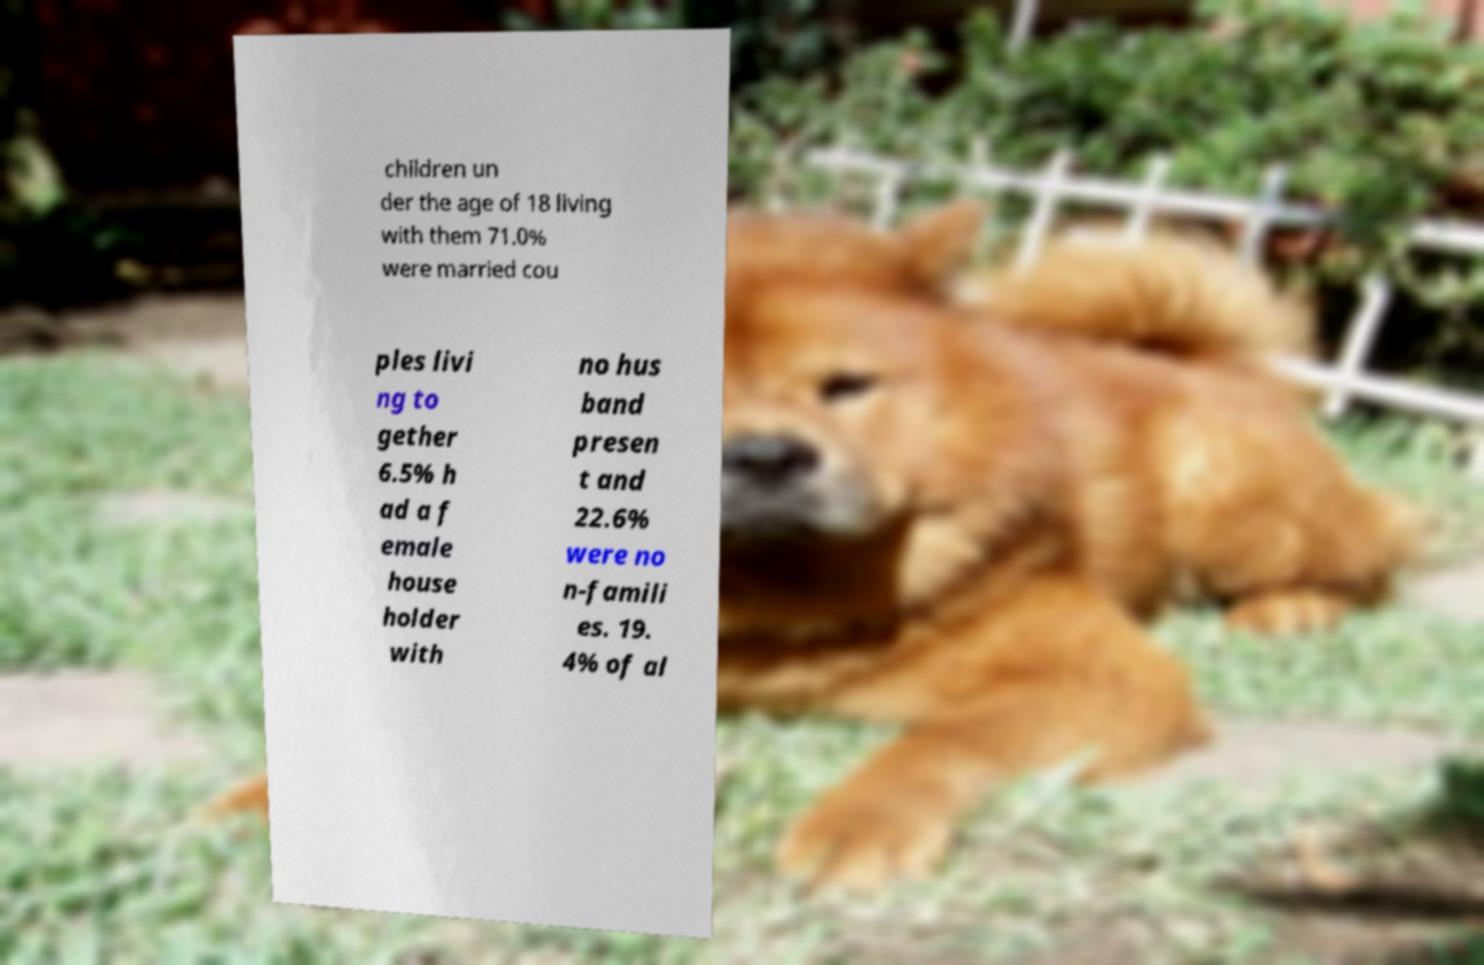Please identify and transcribe the text found in this image. children un der the age of 18 living with them 71.0% were married cou ples livi ng to gether 6.5% h ad a f emale house holder with no hus band presen t and 22.6% were no n-famili es. 19. 4% of al 